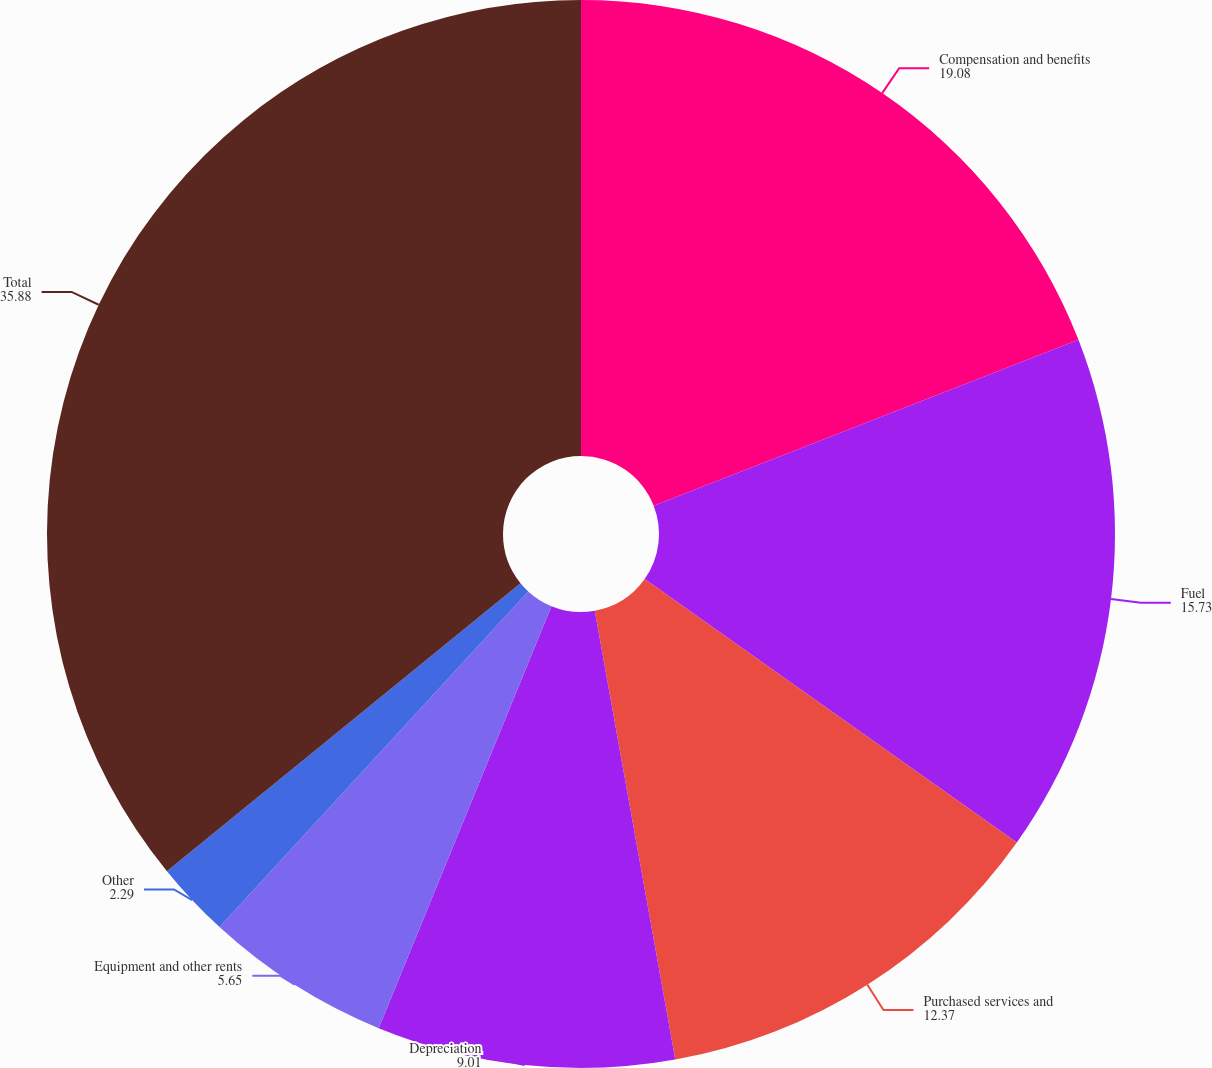Convert chart to OTSL. <chart><loc_0><loc_0><loc_500><loc_500><pie_chart><fcel>Compensation and benefits<fcel>Fuel<fcel>Purchased services and<fcel>Depreciation<fcel>Equipment and other rents<fcel>Other<fcel>Total<nl><fcel>19.08%<fcel>15.73%<fcel>12.37%<fcel>9.01%<fcel>5.65%<fcel>2.29%<fcel>35.88%<nl></chart> 